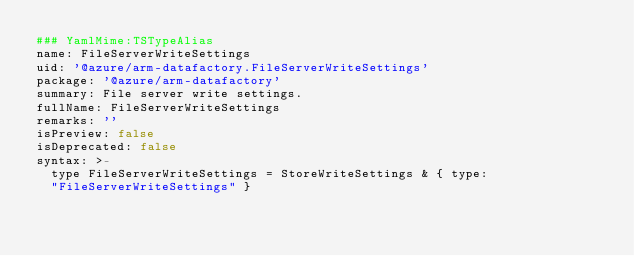Convert code to text. <code><loc_0><loc_0><loc_500><loc_500><_YAML_>### YamlMime:TSTypeAlias
name: FileServerWriteSettings
uid: '@azure/arm-datafactory.FileServerWriteSettings'
package: '@azure/arm-datafactory'
summary: File server write settings.
fullName: FileServerWriteSettings
remarks: ''
isPreview: false
isDeprecated: false
syntax: >-
  type FileServerWriteSettings = StoreWriteSettings & { type:
  "FileServerWriteSettings" }
</code> 